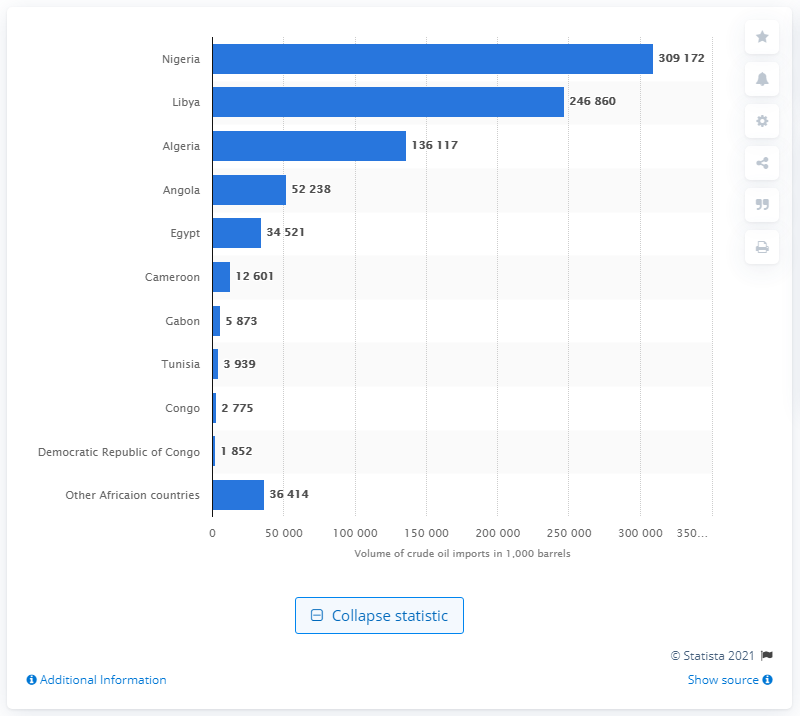List a handful of essential elements in this visual. The majority of crude oil imported into the European Union originates from Nigeria. 